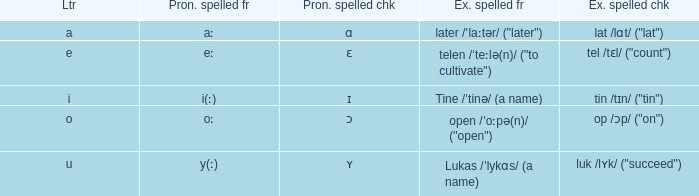What is Example Spelled Free, when Example Spelled Checked is "op /ɔp/ ("on")"? Open /ˈoːpə(n)/ ("open"). 